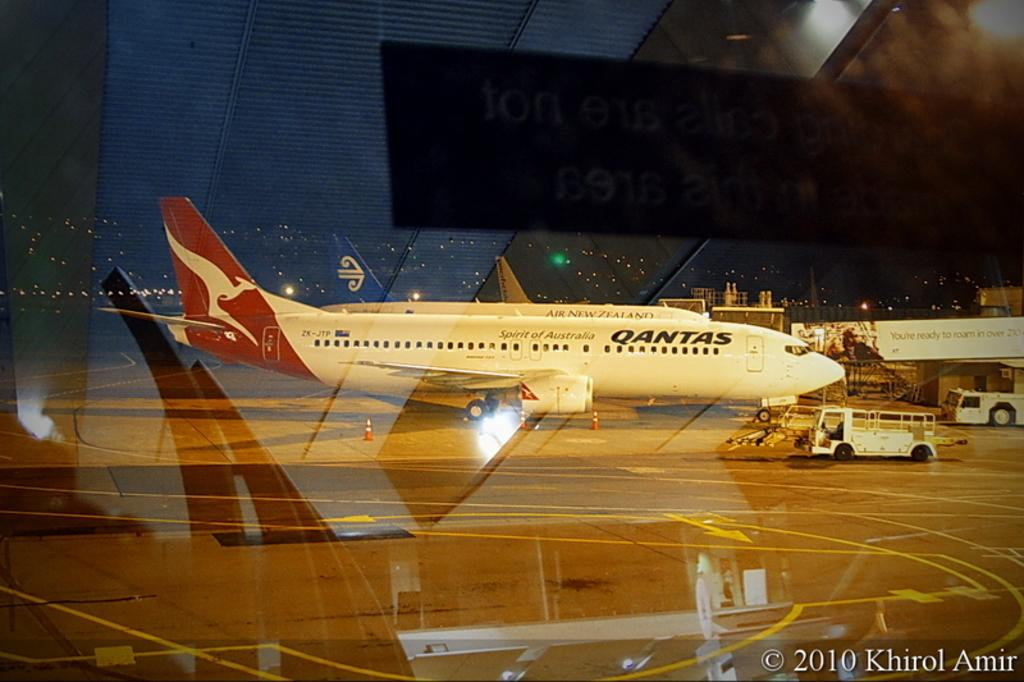<image>
Offer a succinct explanation of the picture presented. A red and white Qantas Airplane sitting on the ground. 